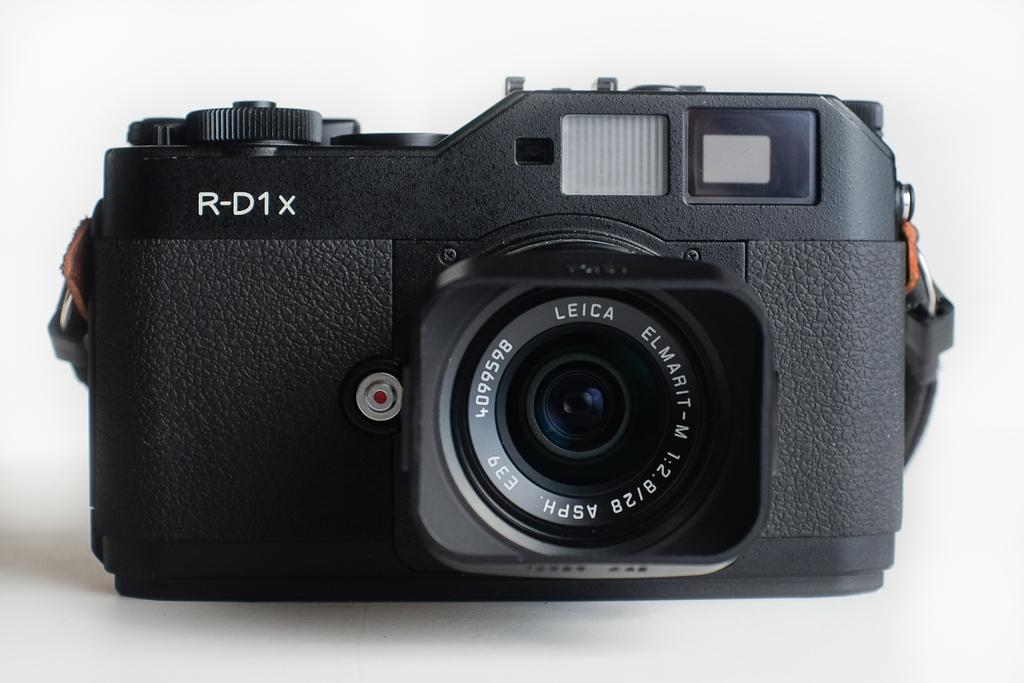What is the main object in the image? There is a camera in the image. What color is the background of the image? The background of the image is white in color. Are there any bushes visible in the image? There are no bushes present in the image; it only features a camera against a white background. 